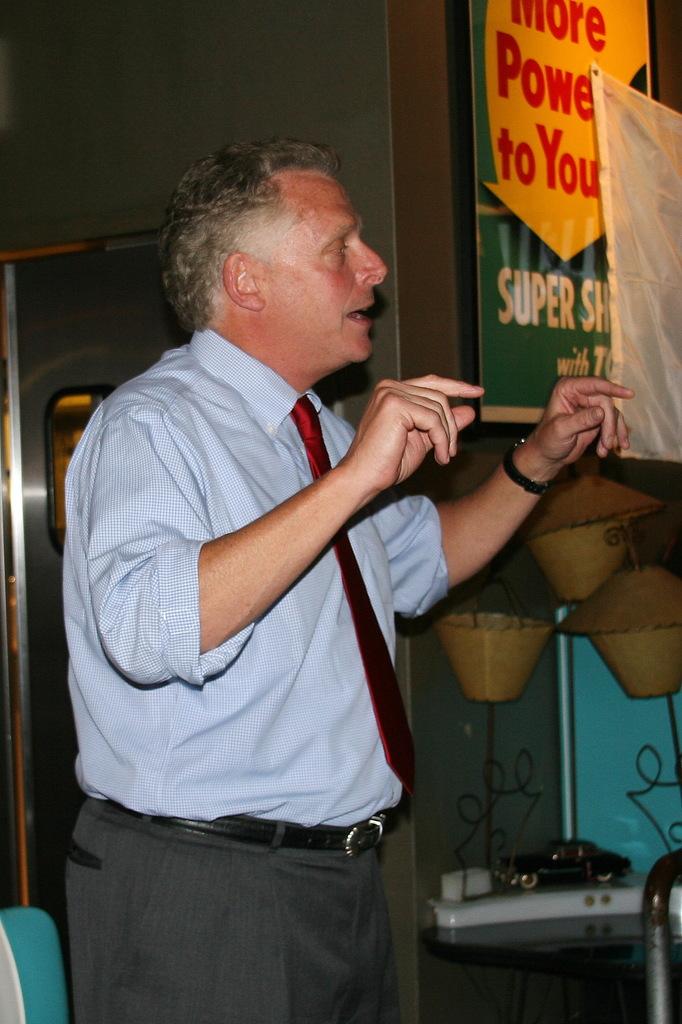What do you get more of according to the sign?
Provide a succinct answer. Power. 